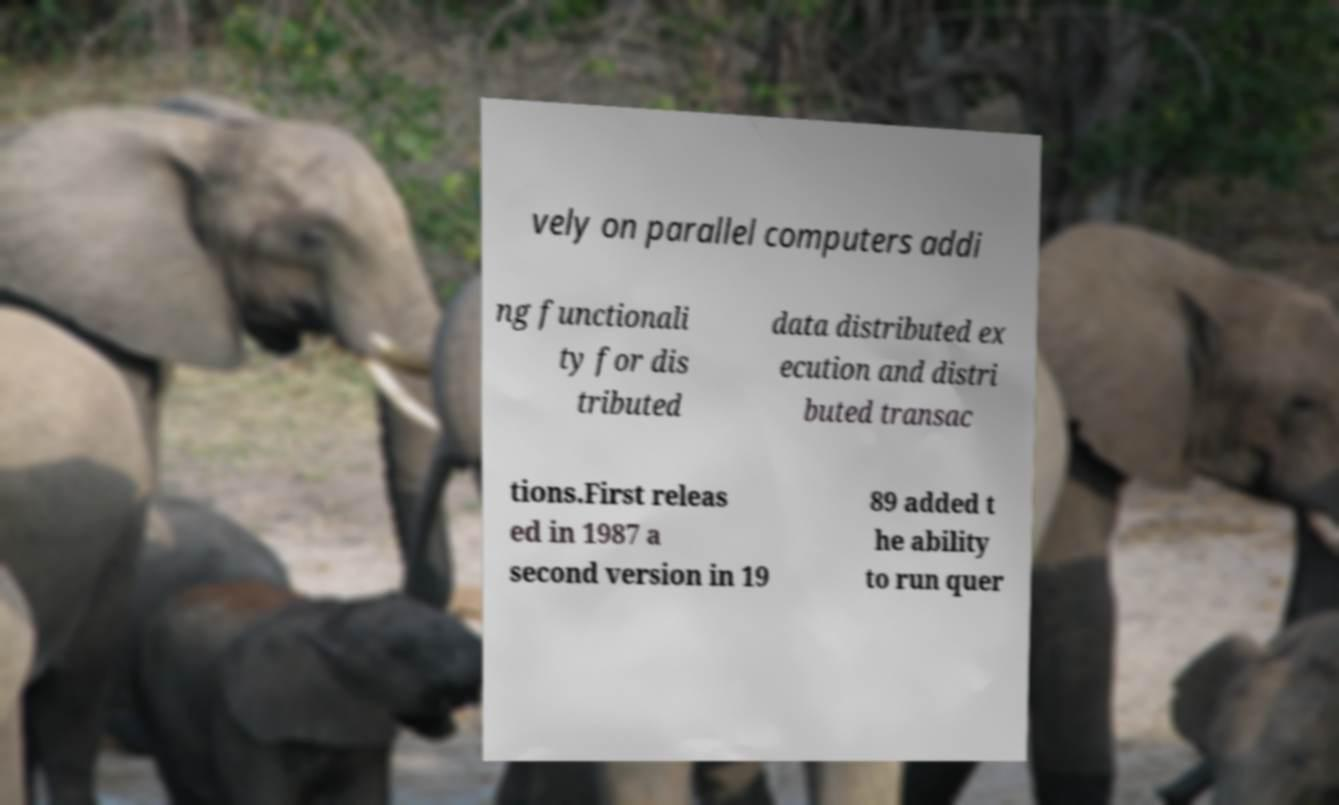Could you assist in decoding the text presented in this image and type it out clearly? vely on parallel computers addi ng functionali ty for dis tributed data distributed ex ecution and distri buted transac tions.First releas ed in 1987 a second version in 19 89 added t he ability to run quer 